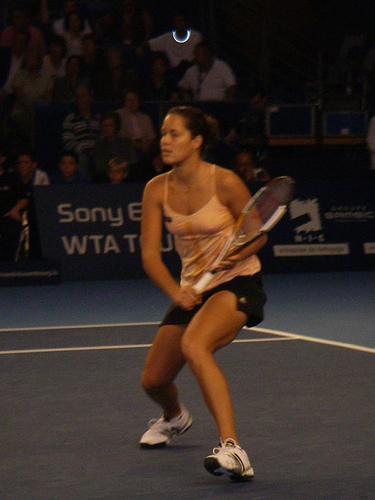What is the woman prepared to do?
Make your selection and explain in format: 'Answer: answer
Rationale: rationale.'
Options: Dunk, swing, run, dribble. Answer: swing.
Rationale: She is waiting for the ball to get closer before she hits it 